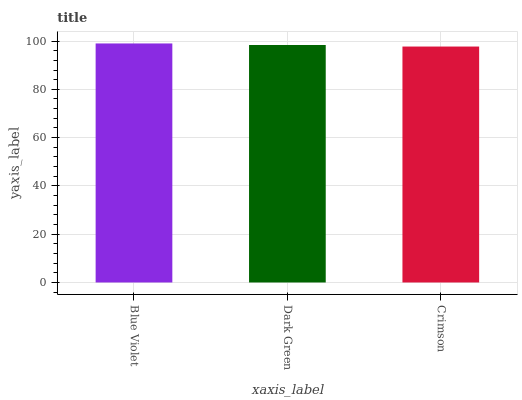Is Crimson the minimum?
Answer yes or no. Yes. Is Blue Violet the maximum?
Answer yes or no. Yes. Is Dark Green the minimum?
Answer yes or no. No. Is Dark Green the maximum?
Answer yes or no. No. Is Blue Violet greater than Dark Green?
Answer yes or no. Yes. Is Dark Green less than Blue Violet?
Answer yes or no. Yes. Is Dark Green greater than Blue Violet?
Answer yes or no. No. Is Blue Violet less than Dark Green?
Answer yes or no. No. Is Dark Green the high median?
Answer yes or no. Yes. Is Dark Green the low median?
Answer yes or no. Yes. Is Crimson the high median?
Answer yes or no. No. Is Blue Violet the low median?
Answer yes or no. No. 